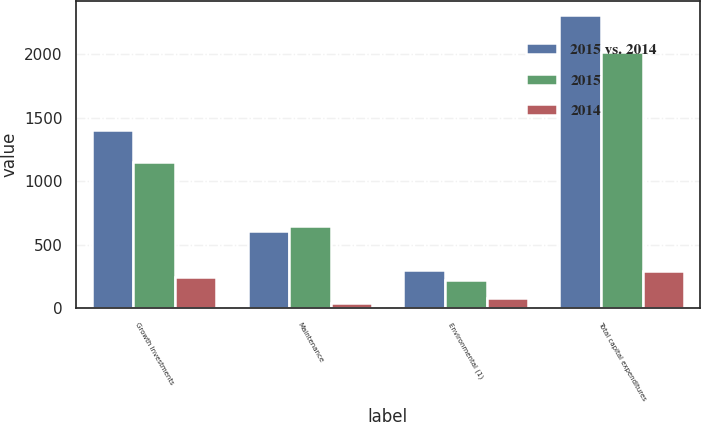Convert chart. <chart><loc_0><loc_0><loc_500><loc_500><stacked_bar_chart><ecel><fcel>Growth Investments<fcel>Maintenance<fcel>Environmental (1)<fcel>Total capital expenditures<nl><fcel>2015 vs. 2014<fcel>1401<fcel>606<fcel>301<fcel>2308<nl><fcel>2015<fcel>1151<fcel>645<fcel>220<fcel>2016<nl><fcel>2014<fcel>250<fcel>39<fcel>81<fcel>292<nl></chart> 